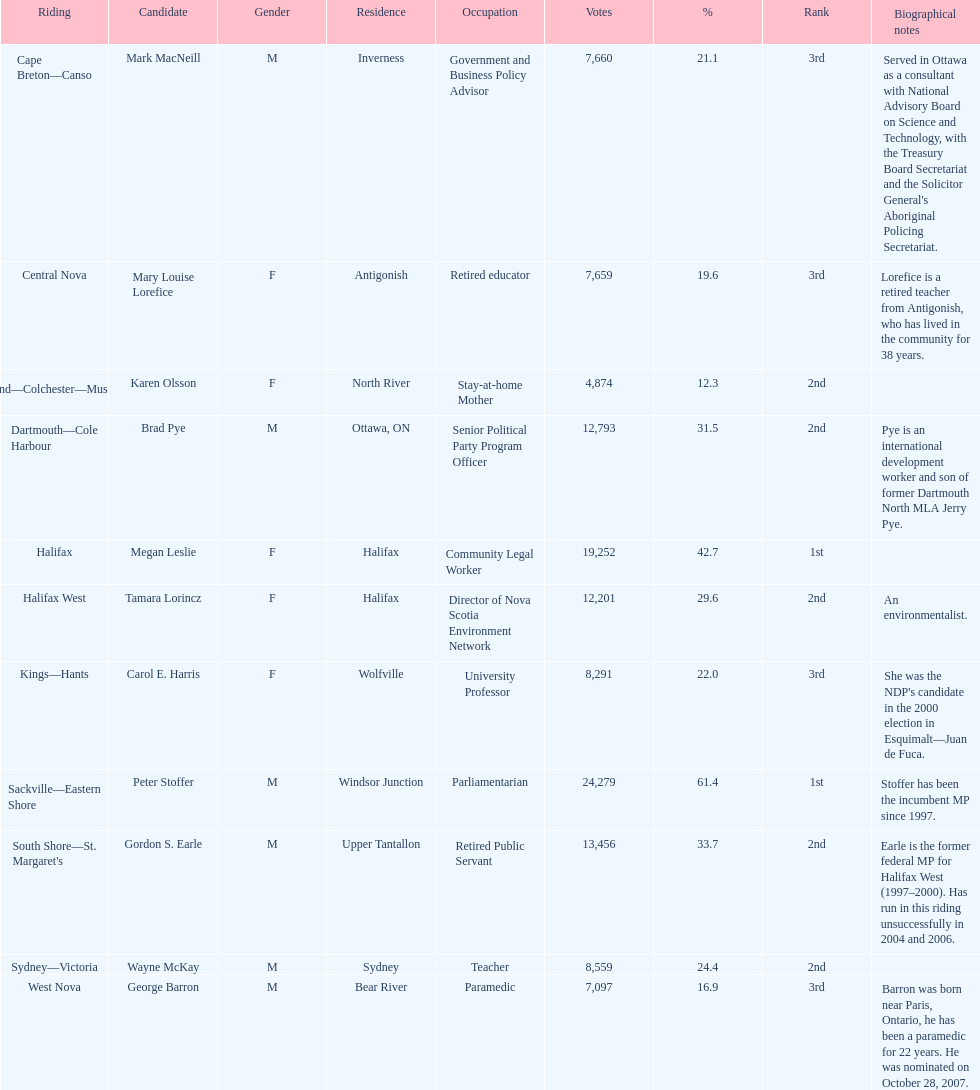Who is the person with the most votes? Sackville-Eastern Shore. 